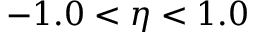<formula> <loc_0><loc_0><loc_500><loc_500>- 1 . 0 < \eta < 1 . 0</formula> 